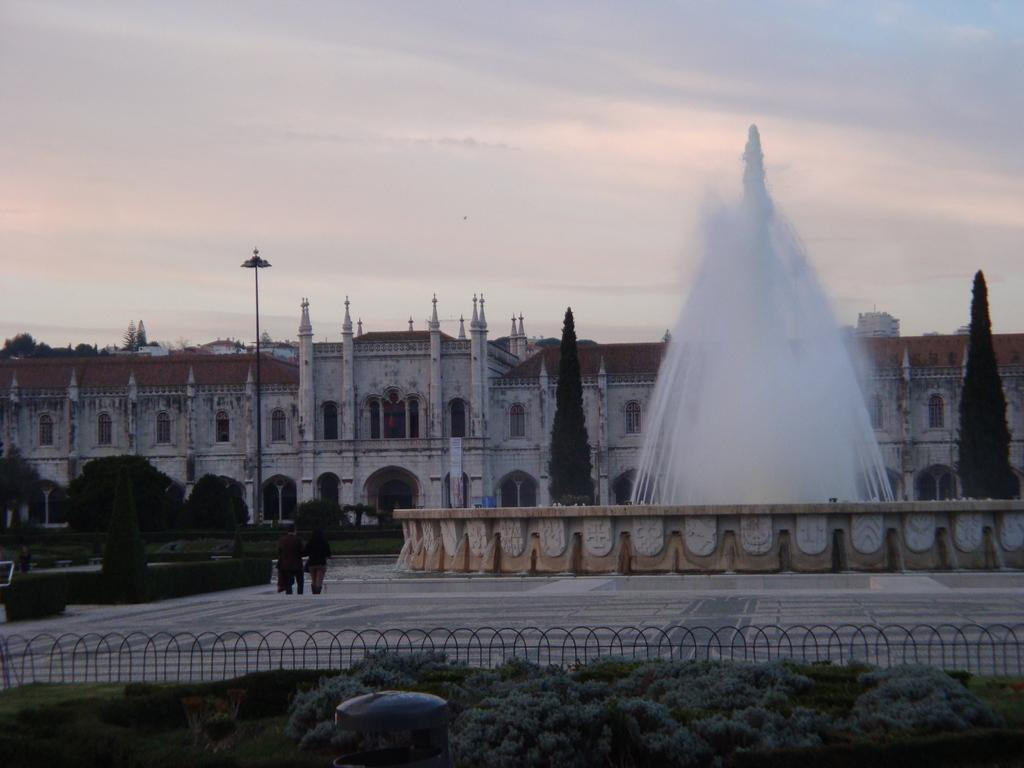What are the people in the image doing? The people in the image are walking on the ground. What can be seen near the ground in the image? There is a fountain at the side of the ground. What type of vegetation is present in the image? There are trees in the image. What type of structure is visible in the image? There is a building in the image. What type of barrier is present in the image? There is a fence in the image. What type of vertical structure is present in the image? There is a pole in the image. What part of the natural environment is visible in the image? The sky is visible in the image. Can you tell me who the father is in the image? There is no reference to a father or any individuals in the image, so it is not possible to identify a father. What type of teaching is being conducted in the image? There is no teaching or educational activity depicted in the image. 